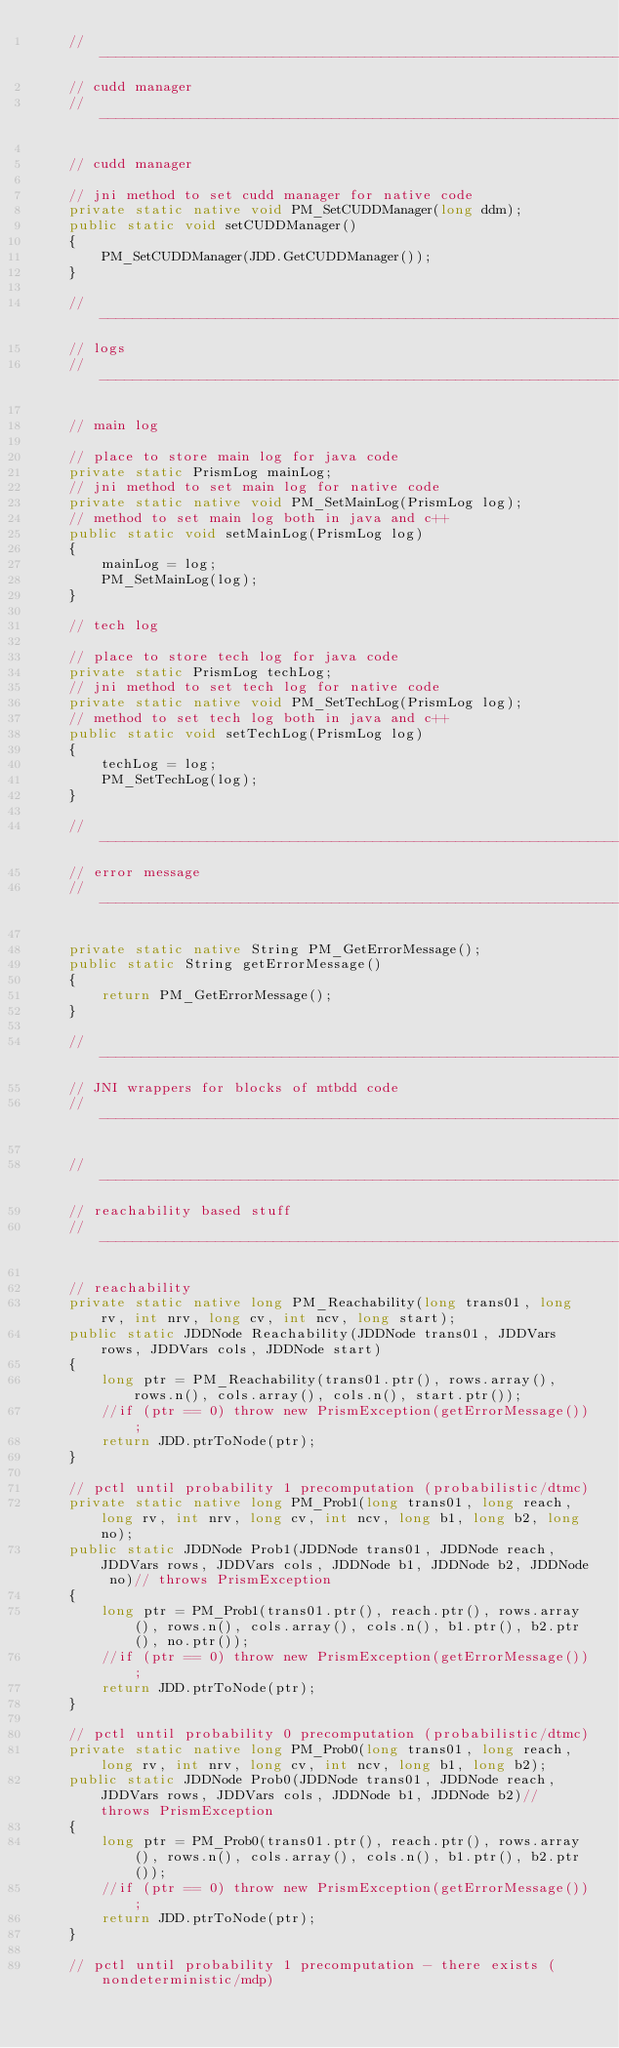<code> <loc_0><loc_0><loc_500><loc_500><_Java_>	//------------------------------------------------------------------------------
	// cudd manager
	//------------------------------------------------------------------------------

	// cudd manager
	
	// jni method to set cudd manager for native code
	private static native void PM_SetCUDDManager(long ddm);
	public static void setCUDDManager()
	{
		PM_SetCUDDManager(JDD.GetCUDDManager());
	}
	
	//------------------------------------------------------------------------------
	// logs
	//------------------------------------------------------------------------------

	// main log
	
	// place to store main log for java code
	private static PrismLog mainLog;
	// jni method to set main log for native code
	private static native void PM_SetMainLog(PrismLog log);
	// method to set main log both in java and c++
	public static void setMainLog(PrismLog log)
	{
		mainLog = log;
		PM_SetMainLog(log);
	}
	
	// tech log
	
	// place to store tech log for java code
	private static PrismLog techLog;
	// jni method to set tech log for native code
	private static native void PM_SetTechLog(PrismLog log);
	// method to set tech log both in java and c++
	public static void setTechLog(PrismLog log)
	{
		techLog = log;
		PM_SetTechLog(log);
	}

	//------------------------------------------------------------------------------
	// error message
	//------------------------------------------------------------------------------
	
	private static native String PM_GetErrorMessage();
	public static String getErrorMessage()
	{
		return PM_GetErrorMessage();
	}

	//------------------------------------------------------------------------------
	// JNI wrappers for blocks of mtbdd code
	//------------------------------------------------------------------------------

	//------------------------------------------------------------------------------
	// reachability based stuff
	//------------------------------------------------------------------------------

	// reachability
	private static native long PM_Reachability(long trans01, long rv, int nrv, long cv, int ncv, long start);
	public static JDDNode Reachability(JDDNode trans01, JDDVars rows, JDDVars cols, JDDNode start)
	{
		long ptr = PM_Reachability(trans01.ptr(), rows.array(), rows.n(), cols.array(), cols.n(), start.ptr());
		//if (ptr == 0) throw new PrismException(getErrorMessage());
		return JDD.ptrToNode(ptr);
	}
	
	// pctl until probability 1 precomputation (probabilistic/dtmc)
	private static native long PM_Prob1(long trans01, long reach, long rv, int nrv, long cv, int ncv, long b1, long b2, long no);
	public static JDDNode Prob1(JDDNode trans01, JDDNode reach,JDDVars rows, JDDVars cols, JDDNode b1, JDDNode b2, JDDNode no)// throws PrismException
	{
		long ptr = PM_Prob1(trans01.ptr(), reach.ptr(), rows.array(), rows.n(), cols.array(), cols.n(), b1.ptr(), b2.ptr(), no.ptr());
		//if (ptr == 0) throw new PrismException(getErrorMessage());
		return JDD.ptrToNode(ptr);
	}
	
	// pctl until probability 0 precomputation (probabilistic/dtmc)
	private static native long PM_Prob0(long trans01, long reach, long rv, int nrv, long cv, int ncv, long b1, long b2);
	public static JDDNode Prob0(JDDNode trans01, JDDNode reach, JDDVars rows, JDDVars cols, JDDNode b1, JDDNode b2)// throws PrismException
	{
		long ptr = PM_Prob0(trans01.ptr(), reach.ptr(), rows.array(), rows.n(), cols.array(), cols.n(), b1.ptr(), b2.ptr());
		//if (ptr == 0) throw new PrismException(getErrorMessage());
		return JDD.ptrToNode(ptr);
	}
	
	// pctl until probability 1 precomputation - there exists (nondeterministic/mdp)</code> 